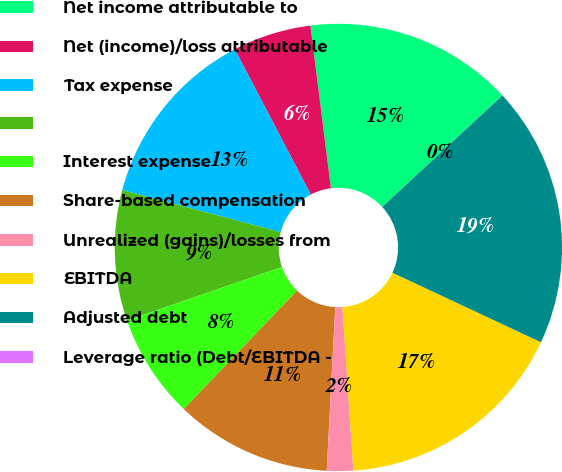Convert chart. <chart><loc_0><loc_0><loc_500><loc_500><pie_chart><fcel>Net income attributable to<fcel>Net (income)/loss attributable<fcel>Tax expense<fcel>Unnamed: 3<fcel>Interest expense<fcel>Share-based compensation<fcel>Unrealized (gains)/losses from<fcel>EBITDA<fcel>Adjusted debt<fcel>Leverage ratio (Debt/EBITDA -<nl><fcel>15.09%<fcel>5.67%<fcel>13.2%<fcel>9.43%<fcel>7.55%<fcel>11.32%<fcel>1.9%<fcel>16.97%<fcel>18.86%<fcel>0.01%<nl></chart> 